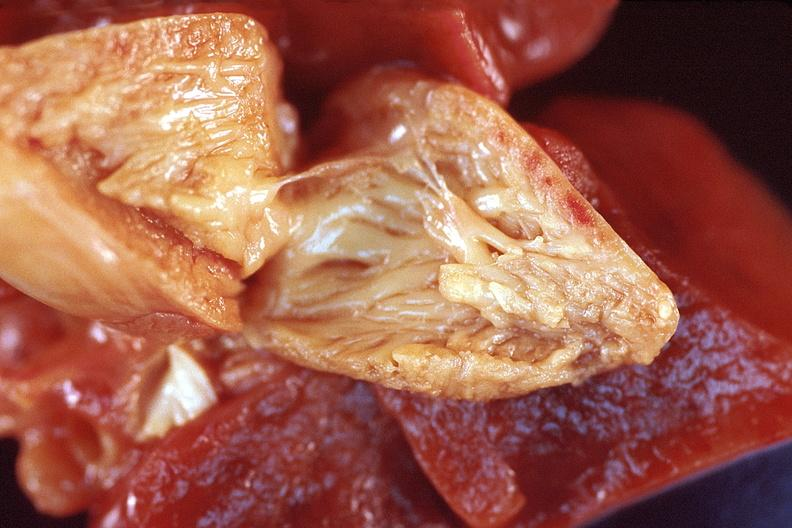s cardiovascular present?
Answer the question using a single word or phrase. Yes 